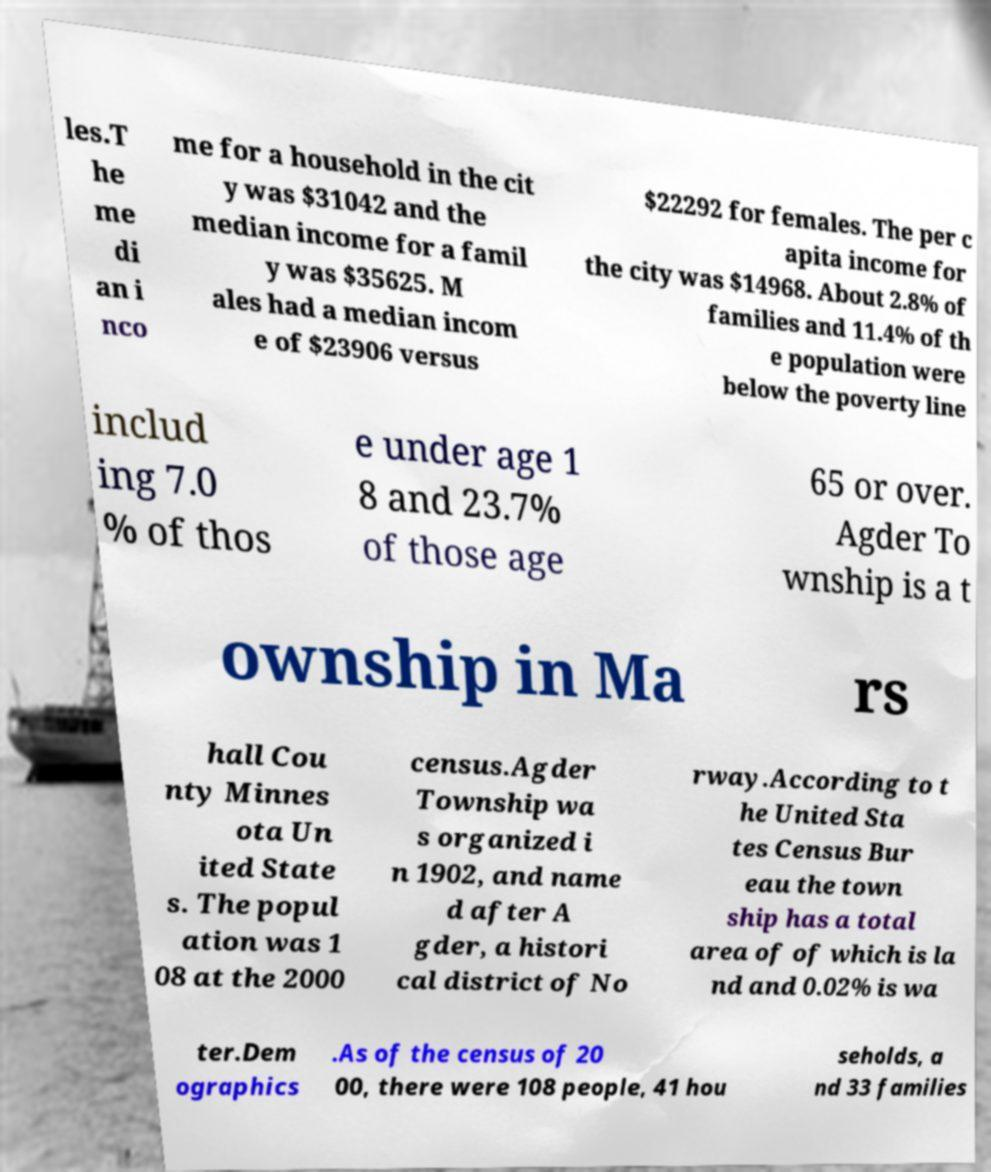Can you accurately transcribe the text from the provided image for me? les.T he me di an i nco me for a household in the cit y was $31042 and the median income for a famil y was $35625. M ales had a median incom e of $23906 versus $22292 for females. The per c apita income for the city was $14968. About 2.8% of families and 11.4% of th e population were below the poverty line includ ing 7.0 % of thos e under age 1 8 and 23.7% of those age 65 or over. Agder To wnship is a t ownship in Ma rs hall Cou nty Minnes ota Un ited State s. The popul ation was 1 08 at the 2000 census.Agder Township wa s organized i n 1902, and name d after A gder, a histori cal district of No rway.According to t he United Sta tes Census Bur eau the town ship has a total area of of which is la nd and 0.02% is wa ter.Dem ographics .As of the census of 20 00, there were 108 people, 41 hou seholds, a nd 33 families 